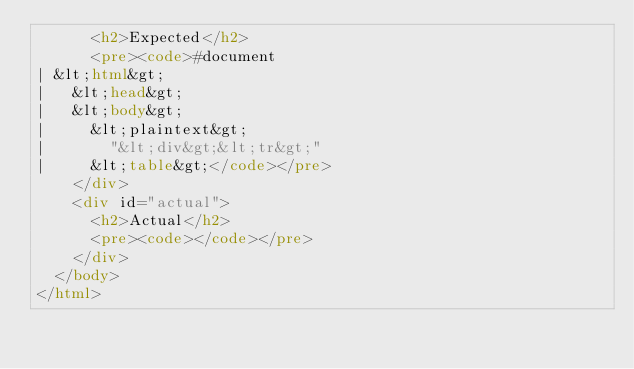Convert code to text. <code><loc_0><loc_0><loc_500><loc_500><_HTML_>      <h2>Expected</h2>
      <pre><code>#document
| &lt;html&gt;
|   &lt;head&gt;
|   &lt;body&gt;
|     &lt;plaintext&gt;
|       "&lt;div&gt;&lt;tr&gt;"
|     &lt;table&gt;</code></pre>
    </div>
    <div id="actual">
      <h2>Actual</h2>
      <pre><code></code></pre>
    </div>
  </body>
</html>
</code> 